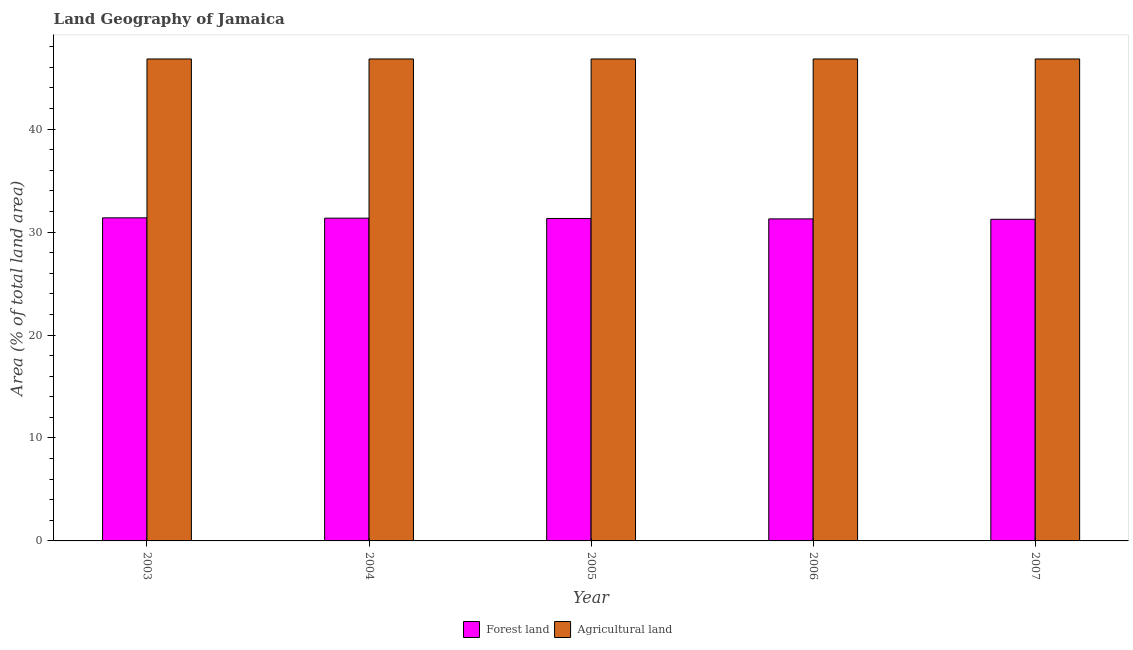How many groups of bars are there?
Your answer should be very brief. 5. Are the number of bars per tick equal to the number of legend labels?
Your response must be concise. Yes. Are the number of bars on each tick of the X-axis equal?
Give a very brief answer. Yes. What is the label of the 2nd group of bars from the left?
Provide a succinct answer. 2004. What is the percentage of land area under agriculture in 2007?
Make the answer very short. 46.81. Across all years, what is the maximum percentage of land area under agriculture?
Provide a succinct answer. 46.81. Across all years, what is the minimum percentage of land area under agriculture?
Make the answer very short. 46.81. What is the total percentage of land area under forests in the graph?
Offer a terse response. 156.58. What is the difference between the percentage of land area under forests in 2004 and that in 2007?
Ensure brevity in your answer.  0.11. What is the difference between the percentage of land area under forests in 2006 and the percentage of land area under agriculture in 2007?
Your response must be concise. 0.04. What is the average percentage of land area under forests per year?
Provide a succinct answer. 31.32. In how many years, is the percentage of land area under agriculture greater than 8 %?
Keep it short and to the point. 5. What is the ratio of the percentage of land area under forests in 2006 to that in 2007?
Your answer should be very brief. 1. What is the difference between the highest and the lowest percentage of land area under agriculture?
Give a very brief answer. 0. What does the 2nd bar from the left in 2003 represents?
Offer a very short reply. Agricultural land. What does the 2nd bar from the right in 2005 represents?
Offer a very short reply. Forest land. Are all the bars in the graph horizontal?
Provide a short and direct response. No. What is the difference between two consecutive major ticks on the Y-axis?
Provide a short and direct response. 10. How many legend labels are there?
Your response must be concise. 2. What is the title of the graph?
Ensure brevity in your answer.  Land Geography of Jamaica. What is the label or title of the Y-axis?
Your response must be concise. Area (% of total land area). What is the Area (% of total land area) in Forest land in 2003?
Your answer should be compact. 31.38. What is the Area (% of total land area) of Agricultural land in 2003?
Your answer should be compact. 46.81. What is the Area (% of total land area) in Forest land in 2004?
Make the answer very short. 31.35. What is the Area (% of total land area) in Agricultural land in 2004?
Make the answer very short. 46.81. What is the Area (% of total land area) of Forest land in 2005?
Your answer should be compact. 31.32. What is the Area (% of total land area) in Agricultural land in 2005?
Provide a succinct answer. 46.81. What is the Area (% of total land area) of Forest land in 2006?
Offer a very short reply. 31.28. What is the Area (% of total land area) in Agricultural land in 2006?
Ensure brevity in your answer.  46.81. What is the Area (% of total land area) of Forest land in 2007?
Keep it short and to the point. 31.24. What is the Area (% of total land area) in Agricultural land in 2007?
Provide a succinct answer. 46.81. Across all years, what is the maximum Area (% of total land area) in Forest land?
Your answer should be very brief. 31.38. Across all years, what is the maximum Area (% of total land area) in Agricultural land?
Your answer should be very brief. 46.81. Across all years, what is the minimum Area (% of total land area) in Forest land?
Offer a terse response. 31.24. Across all years, what is the minimum Area (% of total land area) of Agricultural land?
Offer a terse response. 46.81. What is the total Area (% of total land area) of Forest land in the graph?
Give a very brief answer. 156.58. What is the total Area (% of total land area) of Agricultural land in the graph?
Your answer should be very brief. 234.07. What is the difference between the Area (% of total land area) in Forest land in 2003 and that in 2004?
Provide a short and direct response. 0.03. What is the difference between the Area (% of total land area) of Forest land in 2003 and that in 2005?
Provide a succinct answer. 0.06. What is the difference between the Area (% of total land area) of Forest land in 2003 and that in 2006?
Your answer should be compact. 0.1. What is the difference between the Area (% of total land area) of Forest land in 2003 and that in 2007?
Offer a terse response. 0.14. What is the difference between the Area (% of total land area) of Forest land in 2004 and that in 2005?
Give a very brief answer. 0.03. What is the difference between the Area (% of total land area) in Forest land in 2004 and that in 2006?
Keep it short and to the point. 0.07. What is the difference between the Area (% of total land area) of Forest land in 2004 and that in 2007?
Provide a succinct answer. 0.11. What is the difference between the Area (% of total land area) in Agricultural land in 2004 and that in 2007?
Keep it short and to the point. 0. What is the difference between the Area (% of total land area) in Forest land in 2005 and that in 2006?
Your answer should be compact. 0.04. What is the difference between the Area (% of total land area) in Agricultural land in 2005 and that in 2006?
Give a very brief answer. 0. What is the difference between the Area (% of total land area) of Forest land in 2005 and that in 2007?
Offer a terse response. 0.08. What is the difference between the Area (% of total land area) of Forest land in 2006 and that in 2007?
Provide a succinct answer. 0.04. What is the difference between the Area (% of total land area) of Agricultural land in 2006 and that in 2007?
Make the answer very short. 0. What is the difference between the Area (% of total land area) of Forest land in 2003 and the Area (% of total land area) of Agricultural land in 2004?
Make the answer very short. -15.43. What is the difference between the Area (% of total land area) in Forest land in 2003 and the Area (% of total land area) in Agricultural land in 2005?
Offer a very short reply. -15.43. What is the difference between the Area (% of total land area) in Forest land in 2003 and the Area (% of total land area) in Agricultural land in 2006?
Give a very brief answer. -15.43. What is the difference between the Area (% of total land area) in Forest land in 2003 and the Area (% of total land area) in Agricultural land in 2007?
Ensure brevity in your answer.  -15.43. What is the difference between the Area (% of total land area) of Forest land in 2004 and the Area (% of total land area) of Agricultural land in 2005?
Your answer should be very brief. -15.46. What is the difference between the Area (% of total land area) of Forest land in 2004 and the Area (% of total land area) of Agricultural land in 2006?
Make the answer very short. -15.46. What is the difference between the Area (% of total land area) in Forest land in 2004 and the Area (% of total land area) in Agricultural land in 2007?
Your answer should be compact. -15.46. What is the difference between the Area (% of total land area) in Forest land in 2005 and the Area (% of total land area) in Agricultural land in 2006?
Ensure brevity in your answer.  -15.49. What is the difference between the Area (% of total land area) in Forest land in 2005 and the Area (% of total land area) in Agricultural land in 2007?
Offer a terse response. -15.49. What is the difference between the Area (% of total land area) of Forest land in 2006 and the Area (% of total land area) of Agricultural land in 2007?
Your answer should be very brief. -15.53. What is the average Area (% of total land area) in Forest land per year?
Your answer should be compact. 31.32. What is the average Area (% of total land area) of Agricultural land per year?
Your answer should be very brief. 46.81. In the year 2003, what is the difference between the Area (% of total land area) of Forest land and Area (% of total land area) of Agricultural land?
Provide a short and direct response. -15.43. In the year 2004, what is the difference between the Area (% of total land area) of Forest land and Area (% of total land area) of Agricultural land?
Make the answer very short. -15.46. In the year 2005, what is the difference between the Area (% of total land area) of Forest land and Area (% of total land area) of Agricultural land?
Offer a terse response. -15.49. In the year 2006, what is the difference between the Area (% of total land area) in Forest land and Area (% of total land area) in Agricultural land?
Your answer should be very brief. -15.53. In the year 2007, what is the difference between the Area (% of total land area) of Forest land and Area (% of total land area) of Agricultural land?
Your answer should be very brief. -15.57. What is the ratio of the Area (% of total land area) of Forest land in 2003 to that in 2005?
Ensure brevity in your answer.  1. What is the ratio of the Area (% of total land area) in Forest land in 2003 to that in 2006?
Provide a short and direct response. 1. What is the ratio of the Area (% of total land area) in Forest land in 2003 to that in 2007?
Offer a very short reply. 1. What is the ratio of the Area (% of total land area) of Forest land in 2004 to that in 2005?
Ensure brevity in your answer.  1. What is the ratio of the Area (% of total land area) of Agricultural land in 2004 to that in 2005?
Your response must be concise. 1. What is the ratio of the Area (% of total land area) of Forest land in 2004 to that in 2006?
Your answer should be compact. 1. What is the ratio of the Area (% of total land area) in Agricultural land in 2005 to that in 2006?
Provide a succinct answer. 1. What is the ratio of the Area (% of total land area) of Agricultural land in 2005 to that in 2007?
Offer a very short reply. 1. What is the ratio of the Area (% of total land area) of Agricultural land in 2006 to that in 2007?
Your response must be concise. 1. What is the difference between the highest and the second highest Area (% of total land area) in Forest land?
Make the answer very short. 0.03. What is the difference between the highest and the second highest Area (% of total land area) of Agricultural land?
Offer a very short reply. 0. What is the difference between the highest and the lowest Area (% of total land area) in Forest land?
Offer a very short reply. 0.14. What is the difference between the highest and the lowest Area (% of total land area) of Agricultural land?
Give a very brief answer. 0. 